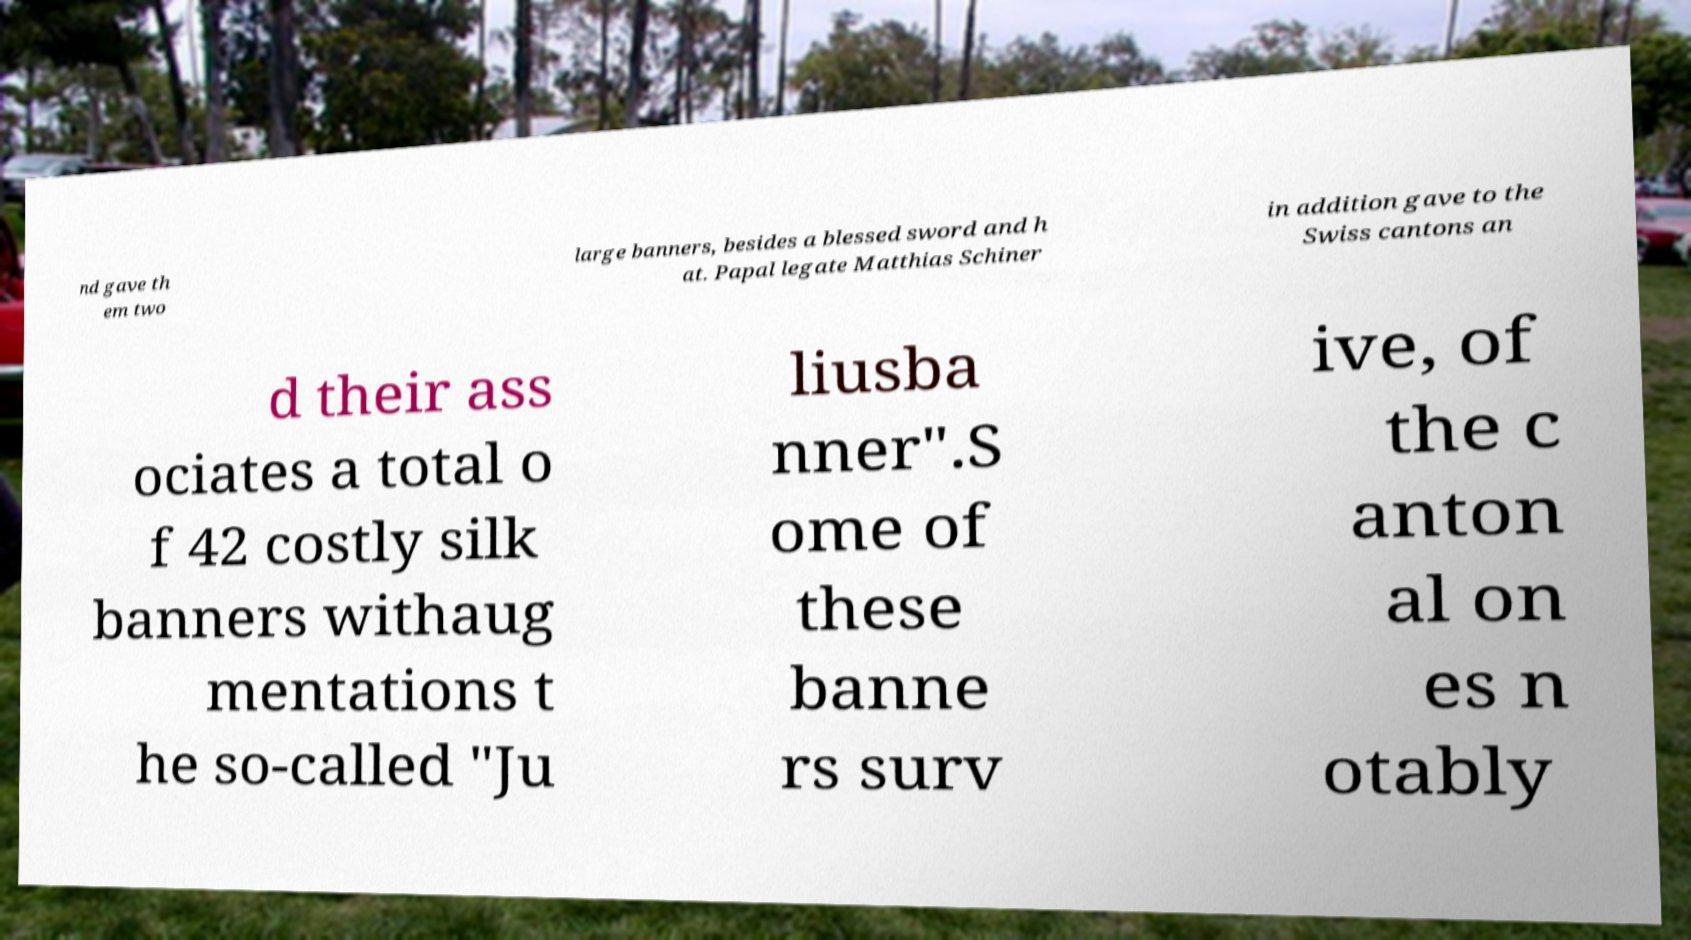There's text embedded in this image that I need extracted. Can you transcribe it verbatim? nd gave th em two large banners, besides a blessed sword and h at. Papal legate Matthias Schiner in addition gave to the Swiss cantons an d their ass ociates a total o f 42 costly silk banners withaug mentations t he so-called "Ju liusba nner".S ome of these banne rs surv ive, of the c anton al on es n otably 